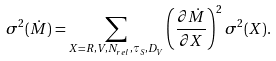<formula> <loc_0><loc_0><loc_500><loc_500>\sigma ^ { 2 } ( \dot { M } ) = \sum _ { X = R , V , N _ { r e l } , \tau _ { S } , D _ { V } } \left ( \frac { \partial \dot { M } } { \partial X } \right ) ^ { 2 } \sigma ^ { 2 } ( X ) .</formula> 